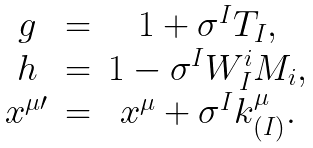Convert formula to latex. <formula><loc_0><loc_0><loc_500><loc_500>\begin{array} { c c c } g & = & 1 + \sigma ^ { I } T _ { I } , \\ h & = & 1 - \sigma ^ { I } W _ { I } ^ { i } M _ { i } , \\ x ^ { \mu \prime } & = & x ^ { \mu } + \sigma ^ { I } k _ { ( I ) } ^ { \mu } . \end{array}</formula> 